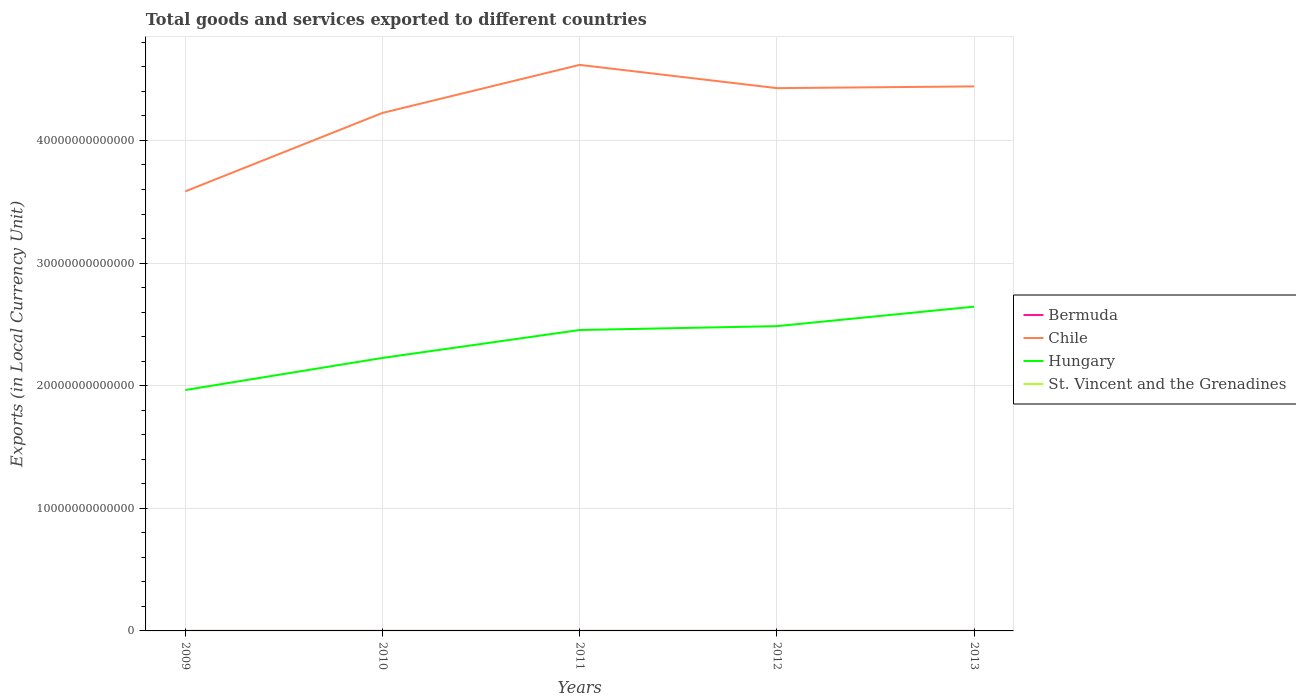How many different coloured lines are there?
Offer a very short reply. 4. Across all years, what is the maximum Amount of goods and services exports in Chile?
Offer a very short reply. 3.58e+13. In which year was the Amount of goods and services exports in Hungary maximum?
Make the answer very short. 2009. What is the total Amount of goods and services exports in Bermuda in the graph?
Your answer should be very brief. 5.48e+07. What is the difference between the highest and the second highest Amount of goods and services exports in Chile?
Your response must be concise. 1.03e+13. What is the difference between the highest and the lowest Amount of goods and services exports in Chile?
Offer a very short reply. 3. What is the difference between two consecutive major ticks on the Y-axis?
Ensure brevity in your answer.  1.00e+13. Does the graph contain grids?
Provide a succinct answer. Yes. How are the legend labels stacked?
Provide a succinct answer. Vertical. What is the title of the graph?
Your answer should be compact. Total goods and services exported to different countries. Does "Chile" appear as one of the legend labels in the graph?
Offer a very short reply. Yes. What is the label or title of the Y-axis?
Ensure brevity in your answer.  Exports (in Local Currency Unit). What is the Exports (in Local Currency Unit) in Bermuda in 2009?
Keep it short and to the point. 2.70e+09. What is the Exports (in Local Currency Unit) in Chile in 2009?
Keep it short and to the point. 3.58e+13. What is the Exports (in Local Currency Unit) of Hungary in 2009?
Your answer should be compact. 1.96e+13. What is the Exports (in Local Currency Unit) of St. Vincent and the Grenadines in 2009?
Ensure brevity in your answer.  5.19e+08. What is the Exports (in Local Currency Unit) of Bermuda in 2010?
Give a very brief answer. 2.70e+09. What is the Exports (in Local Currency Unit) of Chile in 2010?
Offer a terse response. 4.22e+13. What is the Exports (in Local Currency Unit) in Hungary in 2010?
Keep it short and to the point. 2.23e+13. What is the Exports (in Local Currency Unit) of St. Vincent and the Grenadines in 2010?
Your response must be concise. 4.95e+08. What is the Exports (in Local Currency Unit) in Bermuda in 2011?
Offer a very short reply. 2.64e+09. What is the Exports (in Local Currency Unit) in Chile in 2011?
Offer a terse response. 4.62e+13. What is the Exports (in Local Currency Unit) in Hungary in 2011?
Your response must be concise. 2.45e+13. What is the Exports (in Local Currency Unit) in St. Vincent and the Grenadines in 2011?
Your response must be concise. 4.94e+08. What is the Exports (in Local Currency Unit) in Bermuda in 2012?
Give a very brief answer. 2.59e+09. What is the Exports (in Local Currency Unit) of Chile in 2012?
Your answer should be very brief. 4.43e+13. What is the Exports (in Local Currency Unit) in Hungary in 2012?
Ensure brevity in your answer.  2.49e+13. What is the Exports (in Local Currency Unit) of St. Vincent and the Grenadines in 2012?
Provide a succinct answer. 5.15e+08. What is the Exports (in Local Currency Unit) in Bermuda in 2013?
Offer a very short reply. 2.66e+09. What is the Exports (in Local Currency Unit) in Chile in 2013?
Your response must be concise. 4.44e+13. What is the Exports (in Local Currency Unit) in Hungary in 2013?
Provide a succinct answer. 2.64e+13. What is the Exports (in Local Currency Unit) of St. Vincent and the Grenadines in 2013?
Your answer should be compact. 4.91e+08. Across all years, what is the maximum Exports (in Local Currency Unit) of Bermuda?
Provide a succinct answer. 2.70e+09. Across all years, what is the maximum Exports (in Local Currency Unit) of Chile?
Your answer should be very brief. 4.62e+13. Across all years, what is the maximum Exports (in Local Currency Unit) of Hungary?
Ensure brevity in your answer.  2.64e+13. Across all years, what is the maximum Exports (in Local Currency Unit) in St. Vincent and the Grenadines?
Give a very brief answer. 5.19e+08. Across all years, what is the minimum Exports (in Local Currency Unit) in Bermuda?
Ensure brevity in your answer.  2.59e+09. Across all years, what is the minimum Exports (in Local Currency Unit) in Chile?
Provide a short and direct response. 3.58e+13. Across all years, what is the minimum Exports (in Local Currency Unit) in Hungary?
Provide a short and direct response. 1.96e+13. Across all years, what is the minimum Exports (in Local Currency Unit) in St. Vincent and the Grenadines?
Your answer should be compact. 4.91e+08. What is the total Exports (in Local Currency Unit) of Bermuda in the graph?
Make the answer very short. 1.33e+1. What is the total Exports (in Local Currency Unit) in Chile in the graph?
Make the answer very short. 2.13e+14. What is the total Exports (in Local Currency Unit) of Hungary in the graph?
Give a very brief answer. 1.18e+14. What is the total Exports (in Local Currency Unit) of St. Vincent and the Grenadines in the graph?
Offer a terse response. 2.51e+09. What is the difference between the Exports (in Local Currency Unit) in Bermuda in 2009 and that in 2010?
Your response must be concise. -5.34e+06. What is the difference between the Exports (in Local Currency Unit) in Chile in 2009 and that in 2010?
Make the answer very short. -6.40e+12. What is the difference between the Exports (in Local Currency Unit) of Hungary in 2009 and that in 2010?
Offer a terse response. -2.62e+12. What is the difference between the Exports (in Local Currency Unit) in St. Vincent and the Grenadines in 2009 and that in 2010?
Provide a succinct answer. 2.46e+07. What is the difference between the Exports (in Local Currency Unit) of Bermuda in 2009 and that in 2011?
Your answer should be compact. 5.51e+07. What is the difference between the Exports (in Local Currency Unit) of Chile in 2009 and that in 2011?
Provide a short and direct response. -1.03e+13. What is the difference between the Exports (in Local Currency Unit) in Hungary in 2009 and that in 2011?
Offer a very short reply. -4.89e+12. What is the difference between the Exports (in Local Currency Unit) in St. Vincent and the Grenadines in 2009 and that in 2011?
Make the answer very short. 2.57e+07. What is the difference between the Exports (in Local Currency Unit) of Bermuda in 2009 and that in 2012?
Your answer should be compact. 1.10e+08. What is the difference between the Exports (in Local Currency Unit) in Chile in 2009 and that in 2012?
Make the answer very short. -8.42e+12. What is the difference between the Exports (in Local Currency Unit) of Hungary in 2009 and that in 2012?
Provide a short and direct response. -5.21e+12. What is the difference between the Exports (in Local Currency Unit) in St. Vincent and the Grenadines in 2009 and that in 2012?
Keep it short and to the point. 4.42e+06. What is the difference between the Exports (in Local Currency Unit) of Bermuda in 2009 and that in 2013?
Offer a terse response. 4.24e+07. What is the difference between the Exports (in Local Currency Unit) in Chile in 2009 and that in 2013?
Your answer should be compact. -8.56e+12. What is the difference between the Exports (in Local Currency Unit) of Hungary in 2009 and that in 2013?
Your answer should be compact. -6.80e+12. What is the difference between the Exports (in Local Currency Unit) in St. Vincent and the Grenadines in 2009 and that in 2013?
Your answer should be compact. 2.79e+07. What is the difference between the Exports (in Local Currency Unit) in Bermuda in 2010 and that in 2011?
Offer a terse response. 6.04e+07. What is the difference between the Exports (in Local Currency Unit) of Chile in 2010 and that in 2011?
Make the answer very short. -3.92e+12. What is the difference between the Exports (in Local Currency Unit) of Hungary in 2010 and that in 2011?
Offer a very short reply. -2.28e+12. What is the difference between the Exports (in Local Currency Unit) in St. Vincent and the Grenadines in 2010 and that in 2011?
Offer a very short reply. 1.06e+06. What is the difference between the Exports (in Local Currency Unit) of Bermuda in 2010 and that in 2012?
Your answer should be compact. 1.15e+08. What is the difference between the Exports (in Local Currency Unit) of Chile in 2010 and that in 2012?
Your answer should be very brief. -2.02e+12. What is the difference between the Exports (in Local Currency Unit) in Hungary in 2010 and that in 2012?
Make the answer very short. -2.59e+12. What is the difference between the Exports (in Local Currency Unit) of St. Vincent and the Grenadines in 2010 and that in 2012?
Give a very brief answer. -2.02e+07. What is the difference between the Exports (in Local Currency Unit) of Bermuda in 2010 and that in 2013?
Offer a very short reply. 4.78e+07. What is the difference between the Exports (in Local Currency Unit) of Chile in 2010 and that in 2013?
Your answer should be compact. -2.16e+12. What is the difference between the Exports (in Local Currency Unit) of Hungary in 2010 and that in 2013?
Provide a short and direct response. -4.18e+12. What is the difference between the Exports (in Local Currency Unit) of St. Vincent and the Grenadines in 2010 and that in 2013?
Your response must be concise. 3.31e+06. What is the difference between the Exports (in Local Currency Unit) in Bermuda in 2011 and that in 2012?
Ensure brevity in your answer.  5.48e+07. What is the difference between the Exports (in Local Currency Unit) in Chile in 2011 and that in 2012?
Give a very brief answer. 1.90e+12. What is the difference between the Exports (in Local Currency Unit) of Hungary in 2011 and that in 2012?
Provide a short and direct response. -3.15e+11. What is the difference between the Exports (in Local Currency Unit) of St. Vincent and the Grenadines in 2011 and that in 2012?
Provide a succinct answer. -2.13e+07. What is the difference between the Exports (in Local Currency Unit) in Bermuda in 2011 and that in 2013?
Ensure brevity in your answer.  -1.27e+07. What is the difference between the Exports (in Local Currency Unit) of Chile in 2011 and that in 2013?
Provide a short and direct response. 1.76e+12. What is the difference between the Exports (in Local Currency Unit) of Hungary in 2011 and that in 2013?
Keep it short and to the point. -1.90e+12. What is the difference between the Exports (in Local Currency Unit) in St. Vincent and the Grenadines in 2011 and that in 2013?
Provide a succinct answer. 2.26e+06. What is the difference between the Exports (in Local Currency Unit) of Bermuda in 2012 and that in 2013?
Your answer should be very brief. -6.75e+07. What is the difference between the Exports (in Local Currency Unit) in Chile in 2012 and that in 2013?
Keep it short and to the point. -1.41e+11. What is the difference between the Exports (in Local Currency Unit) of Hungary in 2012 and that in 2013?
Keep it short and to the point. -1.59e+12. What is the difference between the Exports (in Local Currency Unit) in St. Vincent and the Grenadines in 2012 and that in 2013?
Provide a short and direct response. 2.35e+07. What is the difference between the Exports (in Local Currency Unit) of Bermuda in 2009 and the Exports (in Local Currency Unit) of Chile in 2010?
Offer a very short reply. -4.22e+13. What is the difference between the Exports (in Local Currency Unit) in Bermuda in 2009 and the Exports (in Local Currency Unit) in Hungary in 2010?
Provide a short and direct response. -2.23e+13. What is the difference between the Exports (in Local Currency Unit) of Bermuda in 2009 and the Exports (in Local Currency Unit) of St. Vincent and the Grenadines in 2010?
Your answer should be compact. 2.20e+09. What is the difference between the Exports (in Local Currency Unit) of Chile in 2009 and the Exports (in Local Currency Unit) of Hungary in 2010?
Your response must be concise. 1.36e+13. What is the difference between the Exports (in Local Currency Unit) of Chile in 2009 and the Exports (in Local Currency Unit) of St. Vincent and the Grenadines in 2010?
Ensure brevity in your answer.  3.58e+13. What is the difference between the Exports (in Local Currency Unit) of Hungary in 2009 and the Exports (in Local Currency Unit) of St. Vincent and the Grenadines in 2010?
Ensure brevity in your answer.  1.96e+13. What is the difference between the Exports (in Local Currency Unit) of Bermuda in 2009 and the Exports (in Local Currency Unit) of Chile in 2011?
Offer a very short reply. -4.62e+13. What is the difference between the Exports (in Local Currency Unit) of Bermuda in 2009 and the Exports (in Local Currency Unit) of Hungary in 2011?
Your response must be concise. -2.45e+13. What is the difference between the Exports (in Local Currency Unit) in Bermuda in 2009 and the Exports (in Local Currency Unit) in St. Vincent and the Grenadines in 2011?
Your answer should be compact. 2.21e+09. What is the difference between the Exports (in Local Currency Unit) of Chile in 2009 and the Exports (in Local Currency Unit) of Hungary in 2011?
Your response must be concise. 1.13e+13. What is the difference between the Exports (in Local Currency Unit) in Chile in 2009 and the Exports (in Local Currency Unit) in St. Vincent and the Grenadines in 2011?
Make the answer very short. 3.58e+13. What is the difference between the Exports (in Local Currency Unit) in Hungary in 2009 and the Exports (in Local Currency Unit) in St. Vincent and the Grenadines in 2011?
Your response must be concise. 1.96e+13. What is the difference between the Exports (in Local Currency Unit) of Bermuda in 2009 and the Exports (in Local Currency Unit) of Chile in 2012?
Ensure brevity in your answer.  -4.43e+13. What is the difference between the Exports (in Local Currency Unit) of Bermuda in 2009 and the Exports (in Local Currency Unit) of Hungary in 2012?
Provide a succinct answer. -2.49e+13. What is the difference between the Exports (in Local Currency Unit) of Bermuda in 2009 and the Exports (in Local Currency Unit) of St. Vincent and the Grenadines in 2012?
Offer a very short reply. 2.18e+09. What is the difference between the Exports (in Local Currency Unit) in Chile in 2009 and the Exports (in Local Currency Unit) in Hungary in 2012?
Provide a short and direct response. 1.10e+13. What is the difference between the Exports (in Local Currency Unit) of Chile in 2009 and the Exports (in Local Currency Unit) of St. Vincent and the Grenadines in 2012?
Make the answer very short. 3.58e+13. What is the difference between the Exports (in Local Currency Unit) of Hungary in 2009 and the Exports (in Local Currency Unit) of St. Vincent and the Grenadines in 2012?
Your answer should be compact. 1.96e+13. What is the difference between the Exports (in Local Currency Unit) in Bermuda in 2009 and the Exports (in Local Currency Unit) in Chile in 2013?
Your response must be concise. -4.44e+13. What is the difference between the Exports (in Local Currency Unit) in Bermuda in 2009 and the Exports (in Local Currency Unit) in Hungary in 2013?
Provide a succinct answer. -2.64e+13. What is the difference between the Exports (in Local Currency Unit) of Bermuda in 2009 and the Exports (in Local Currency Unit) of St. Vincent and the Grenadines in 2013?
Give a very brief answer. 2.21e+09. What is the difference between the Exports (in Local Currency Unit) in Chile in 2009 and the Exports (in Local Currency Unit) in Hungary in 2013?
Offer a terse response. 9.40e+12. What is the difference between the Exports (in Local Currency Unit) in Chile in 2009 and the Exports (in Local Currency Unit) in St. Vincent and the Grenadines in 2013?
Give a very brief answer. 3.58e+13. What is the difference between the Exports (in Local Currency Unit) in Hungary in 2009 and the Exports (in Local Currency Unit) in St. Vincent and the Grenadines in 2013?
Ensure brevity in your answer.  1.96e+13. What is the difference between the Exports (in Local Currency Unit) of Bermuda in 2010 and the Exports (in Local Currency Unit) of Chile in 2011?
Your answer should be compact. -4.62e+13. What is the difference between the Exports (in Local Currency Unit) of Bermuda in 2010 and the Exports (in Local Currency Unit) of Hungary in 2011?
Ensure brevity in your answer.  -2.45e+13. What is the difference between the Exports (in Local Currency Unit) in Bermuda in 2010 and the Exports (in Local Currency Unit) in St. Vincent and the Grenadines in 2011?
Your response must be concise. 2.21e+09. What is the difference between the Exports (in Local Currency Unit) in Chile in 2010 and the Exports (in Local Currency Unit) in Hungary in 2011?
Your response must be concise. 1.77e+13. What is the difference between the Exports (in Local Currency Unit) in Chile in 2010 and the Exports (in Local Currency Unit) in St. Vincent and the Grenadines in 2011?
Provide a short and direct response. 4.22e+13. What is the difference between the Exports (in Local Currency Unit) in Hungary in 2010 and the Exports (in Local Currency Unit) in St. Vincent and the Grenadines in 2011?
Your answer should be very brief. 2.23e+13. What is the difference between the Exports (in Local Currency Unit) in Bermuda in 2010 and the Exports (in Local Currency Unit) in Chile in 2012?
Keep it short and to the point. -4.43e+13. What is the difference between the Exports (in Local Currency Unit) of Bermuda in 2010 and the Exports (in Local Currency Unit) of Hungary in 2012?
Your response must be concise. -2.49e+13. What is the difference between the Exports (in Local Currency Unit) of Bermuda in 2010 and the Exports (in Local Currency Unit) of St. Vincent and the Grenadines in 2012?
Provide a succinct answer. 2.19e+09. What is the difference between the Exports (in Local Currency Unit) of Chile in 2010 and the Exports (in Local Currency Unit) of Hungary in 2012?
Your answer should be very brief. 1.74e+13. What is the difference between the Exports (in Local Currency Unit) in Chile in 2010 and the Exports (in Local Currency Unit) in St. Vincent and the Grenadines in 2012?
Make the answer very short. 4.22e+13. What is the difference between the Exports (in Local Currency Unit) of Hungary in 2010 and the Exports (in Local Currency Unit) of St. Vincent and the Grenadines in 2012?
Your answer should be compact. 2.23e+13. What is the difference between the Exports (in Local Currency Unit) of Bermuda in 2010 and the Exports (in Local Currency Unit) of Chile in 2013?
Make the answer very short. -4.44e+13. What is the difference between the Exports (in Local Currency Unit) in Bermuda in 2010 and the Exports (in Local Currency Unit) in Hungary in 2013?
Your answer should be very brief. -2.64e+13. What is the difference between the Exports (in Local Currency Unit) in Bermuda in 2010 and the Exports (in Local Currency Unit) in St. Vincent and the Grenadines in 2013?
Provide a succinct answer. 2.21e+09. What is the difference between the Exports (in Local Currency Unit) in Chile in 2010 and the Exports (in Local Currency Unit) in Hungary in 2013?
Give a very brief answer. 1.58e+13. What is the difference between the Exports (in Local Currency Unit) in Chile in 2010 and the Exports (in Local Currency Unit) in St. Vincent and the Grenadines in 2013?
Provide a short and direct response. 4.22e+13. What is the difference between the Exports (in Local Currency Unit) in Hungary in 2010 and the Exports (in Local Currency Unit) in St. Vincent and the Grenadines in 2013?
Offer a very short reply. 2.23e+13. What is the difference between the Exports (in Local Currency Unit) in Bermuda in 2011 and the Exports (in Local Currency Unit) in Chile in 2012?
Your response must be concise. -4.43e+13. What is the difference between the Exports (in Local Currency Unit) in Bermuda in 2011 and the Exports (in Local Currency Unit) in Hungary in 2012?
Your response must be concise. -2.49e+13. What is the difference between the Exports (in Local Currency Unit) in Bermuda in 2011 and the Exports (in Local Currency Unit) in St. Vincent and the Grenadines in 2012?
Offer a terse response. 2.13e+09. What is the difference between the Exports (in Local Currency Unit) of Chile in 2011 and the Exports (in Local Currency Unit) of Hungary in 2012?
Your answer should be compact. 2.13e+13. What is the difference between the Exports (in Local Currency Unit) of Chile in 2011 and the Exports (in Local Currency Unit) of St. Vincent and the Grenadines in 2012?
Your answer should be very brief. 4.62e+13. What is the difference between the Exports (in Local Currency Unit) in Hungary in 2011 and the Exports (in Local Currency Unit) in St. Vincent and the Grenadines in 2012?
Your answer should be very brief. 2.45e+13. What is the difference between the Exports (in Local Currency Unit) of Bermuda in 2011 and the Exports (in Local Currency Unit) of Chile in 2013?
Give a very brief answer. -4.44e+13. What is the difference between the Exports (in Local Currency Unit) in Bermuda in 2011 and the Exports (in Local Currency Unit) in Hungary in 2013?
Your response must be concise. -2.64e+13. What is the difference between the Exports (in Local Currency Unit) of Bermuda in 2011 and the Exports (in Local Currency Unit) of St. Vincent and the Grenadines in 2013?
Ensure brevity in your answer.  2.15e+09. What is the difference between the Exports (in Local Currency Unit) in Chile in 2011 and the Exports (in Local Currency Unit) in Hungary in 2013?
Provide a succinct answer. 1.97e+13. What is the difference between the Exports (in Local Currency Unit) of Chile in 2011 and the Exports (in Local Currency Unit) of St. Vincent and the Grenadines in 2013?
Your answer should be compact. 4.62e+13. What is the difference between the Exports (in Local Currency Unit) of Hungary in 2011 and the Exports (in Local Currency Unit) of St. Vincent and the Grenadines in 2013?
Offer a very short reply. 2.45e+13. What is the difference between the Exports (in Local Currency Unit) in Bermuda in 2012 and the Exports (in Local Currency Unit) in Chile in 2013?
Provide a succinct answer. -4.44e+13. What is the difference between the Exports (in Local Currency Unit) in Bermuda in 2012 and the Exports (in Local Currency Unit) in Hungary in 2013?
Make the answer very short. -2.64e+13. What is the difference between the Exports (in Local Currency Unit) in Bermuda in 2012 and the Exports (in Local Currency Unit) in St. Vincent and the Grenadines in 2013?
Make the answer very short. 2.10e+09. What is the difference between the Exports (in Local Currency Unit) of Chile in 2012 and the Exports (in Local Currency Unit) of Hungary in 2013?
Keep it short and to the point. 1.78e+13. What is the difference between the Exports (in Local Currency Unit) of Chile in 2012 and the Exports (in Local Currency Unit) of St. Vincent and the Grenadines in 2013?
Provide a short and direct response. 4.43e+13. What is the difference between the Exports (in Local Currency Unit) of Hungary in 2012 and the Exports (in Local Currency Unit) of St. Vincent and the Grenadines in 2013?
Ensure brevity in your answer.  2.49e+13. What is the average Exports (in Local Currency Unit) of Bermuda per year?
Provide a succinct answer. 2.66e+09. What is the average Exports (in Local Currency Unit) in Chile per year?
Make the answer very short. 4.26e+13. What is the average Exports (in Local Currency Unit) of Hungary per year?
Keep it short and to the point. 2.36e+13. What is the average Exports (in Local Currency Unit) in St. Vincent and the Grenadines per year?
Your response must be concise. 5.03e+08. In the year 2009, what is the difference between the Exports (in Local Currency Unit) in Bermuda and Exports (in Local Currency Unit) in Chile?
Keep it short and to the point. -3.58e+13. In the year 2009, what is the difference between the Exports (in Local Currency Unit) in Bermuda and Exports (in Local Currency Unit) in Hungary?
Your response must be concise. -1.96e+13. In the year 2009, what is the difference between the Exports (in Local Currency Unit) of Bermuda and Exports (in Local Currency Unit) of St. Vincent and the Grenadines?
Make the answer very short. 2.18e+09. In the year 2009, what is the difference between the Exports (in Local Currency Unit) in Chile and Exports (in Local Currency Unit) in Hungary?
Your answer should be compact. 1.62e+13. In the year 2009, what is the difference between the Exports (in Local Currency Unit) of Chile and Exports (in Local Currency Unit) of St. Vincent and the Grenadines?
Offer a very short reply. 3.58e+13. In the year 2009, what is the difference between the Exports (in Local Currency Unit) in Hungary and Exports (in Local Currency Unit) in St. Vincent and the Grenadines?
Your response must be concise. 1.96e+13. In the year 2010, what is the difference between the Exports (in Local Currency Unit) in Bermuda and Exports (in Local Currency Unit) in Chile?
Provide a succinct answer. -4.22e+13. In the year 2010, what is the difference between the Exports (in Local Currency Unit) in Bermuda and Exports (in Local Currency Unit) in Hungary?
Your response must be concise. -2.23e+13. In the year 2010, what is the difference between the Exports (in Local Currency Unit) in Bermuda and Exports (in Local Currency Unit) in St. Vincent and the Grenadines?
Keep it short and to the point. 2.21e+09. In the year 2010, what is the difference between the Exports (in Local Currency Unit) of Chile and Exports (in Local Currency Unit) of Hungary?
Ensure brevity in your answer.  2.00e+13. In the year 2010, what is the difference between the Exports (in Local Currency Unit) of Chile and Exports (in Local Currency Unit) of St. Vincent and the Grenadines?
Offer a very short reply. 4.22e+13. In the year 2010, what is the difference between the Exports (in Local Currency Unit) in Hungary and Exports (in Local Currency Unit) in St. Vincent and the Grenadines?
Provide a succinct answer. 2.23e+13. In the year 2011, what is the difference between the Exports (in Local Currency Unit) of Bermuda and Exports (in Local Currency Unit) of Chile?
Provide a short and direct response. -4.62e+13. In the year 2011, what is the difference between the Exports (in Local Currency Unit) in Bermuda and Exports (in Local Currency Unit) in Hungary?
Keep it short and to the point. -2.45e+13. In the year 2011, what is the difference between the Exports (in Local Currency Unit) of Bermuda and Exports (in Local Currency Unit) of St. Vincent and the Grenadines?
Provide a short and direct response. 2.15e+09. In the year 2011, what is the difference between the Exports (in Local Currency Unit) of Chile and Exports (in Local Currency Unit) of Hungary?
Your answer should be compact. 2.16e+13. In the year 2011, what is the difference between the Exports (in Local Currency Unit) in Chile and Exports (in Local Currency Unit) in St. Vincent and the Grenadines?
Provide a succinct answer. 4.62e+13. In the year 2011, what is the difference between the Exports (in Local Currency Unit) of Hungary and Exports (in Local Currency Unit) of St. Vincent and the Grenadines?
Provide a short and direct response. 2.45e+13. In the year 2012, what is the difference between the Exports (in Local Currency Unit) in Bermuda and Exports (in Local Currency Unit) in Chile?
Make the answer very short. -4.43e+13. In the year 2012, what is the difference between the Exports (in Local Currency Unit) of Bermuda and Exports (in Local Currency Unit) of Hungary?
Provide a short and direct response. -2.49e+13. In the year 2012, what is the difference between the Exports (in Local Currency Unit) in Bermuda and Exports (in Local Currency Unit) in St. Vincent and the Grenadines?
Make the answer very short. 2.07e+09. In the year 2012, what is the difference between the Exports (in Local Currency Unit) in Chile and Exports (in Local Currency Unit) in Hungary?
Your response must be concise. 1.94e+13. In the year 2012, what is the difference between the Exports (in Local Currency Unit) in Chile and Exports (in Local Currency Unit) in St. Vincent and the Grenadines?
Offer a very short reply. 4.43e+13. In the year 2012, what is the difference between the Exports (in Local Currency Unit) in Hungary and Exports (in Local Currency Unit) in St. Vincent and the Grenadines?
Ensure brevity in your answer.  2.49e+13. In the year 2013, what is the difference between the Exports (in Local Currency Unit) of Bermuda and Exports (in Local Currency Unit) of Chile?
Your answer should be very brief. -4.44e+13. In the year 2013, what is the difference between the Exports (in Local Currency Unit) of Bermuda and Exports (in Local Currency Unit) of Hungary?
Your response must be concise. -2.64e+13. In the year 2013, what is the difference between the Exports (in Local Currency Unit) of Bermuda and Exports (in Local Currency Unit) of St. Vincent and the Grenadines?
Keep it short and to the point. 2.17e+09. In the year 2013, what is the difference between the Exports (in Local Currency Unit) in Chile and Exports (in Local Currency Unit) in Hungary?
Your answer should be compact. 1.80e+13. In the year 2013, what is the difference between the Exports (in Local Currency Unit) of Chile and Exports (in Local Currency Unit) of St. Vincent and the Grenadines?
Keep it short and to the point. 4.44e+13. In the year 2013, what is the difference between the Exports (in Local Currency Unit) of Hungary and Exports (in Local Currency Unit) of St. Vincent and the Grenadines?
Offer a terse response. 2.64e+13. What is the ratio of the Exports (in Local Currency Unit) in Chile in 2009 to that in 2010?
Your response must be concise. 0.85. What is the ratio of the Exports (in Local Currency Unit) of Hungary in 2009 to that in 2010?
Ensure brevity in your answer.  0.88. What is the ratio of the Exports (in Local Currency Unit) in St. Vincent and the Grenadines in 2009 to that in 2010?
Your answer should be very brief. 1.05. What is the ratio of the Exports (in Local Currency Unit) of Bermuda in 2009 to that in 2011?
Your response must be concise. 1.02. What is the ratio of the Exports (in Local Currency Unit) of Chile in 2009 to that in 2011?
Your answer should be very brief. 0.78. What is the ratio of the Exports (in Local Currency Unit) of Hungary in 2009 to that in 2011?
Your answer should be compact. 0.8. What is the ratio of the Exports (in Local Currency Unit) in St. Vincent and the Grenadines in 2009 to that in 2011?
Offer a very short reply. 1.05. What is the ratio of the Exports (in Local Currency Unit) in Bermuda in 2009 to that in 2012?
Offer a terse response. 1.04. What is the ratio of the Exports (in Local Currency Unit) in Chile in 2009 to that in 2012?
Your answer should be compact. 0.81. What is the ratio of the Exports (in Local Currency Unit) of Hungary in 2009 to that in 2012?
Your answer should be very brief. 0.79. What is the ratio of the Exports (in Local Currency Unit) of St. Vincent and the Grenadines in 2009 to that in 2012?
Give a very brief answer. 1.01. What is the ratio of the Exports (in Local Currency Unit) in Bermuda in 2009 to that in 2013?
Provide a succinct answer. 1.02. What is the ratio of the Exports (in Local Currency Unit) in Chile in 2009 to that in 2013?
Keep it short and to the point. 0.81. What is the ratio of the Exports (in Local Currency Unit) in Hungary in 2009 to that in 2013?
Ensure brevity in your answer.  0.74. What is the ratio of the Exports (in Local Currency Unit) of St. Vincent and the Grenadines in 2009 to that in 2013?
Provide a short and direct response. 1.06. What is the ratio of the Exports (in Local Currency Unit) in Bermuda in 2010 to that in 2011?
Your answer should be very brief. 1.02. What is the ratio of the Exports (in Local Currency Unit) of Chile in 2010 to that in 2011?
Provide a succinct answer. 0.92. What is the ratio of the Exports (in Local Currency Unit) in Hungary in 2010 to that in 2011?
Give a very brief answer. 0.91. What is the ratio of the Exports (in Local Currency Unit) of St. Vincent and the Grenadines in 2010 to that in 2011?
Your response must be concise. 1. What is the ratio of the Exports (in Local Currency Unit) of Bermuda in 2010 to that in 2012?
Ensure brevity in your answer.  1.04. What is the ratio of the Exports (in Local Currency Unit) of Chile in 2010 to that in 2012?
Provide a short and direct response. 0.95. What is the ratio of the Exports (in Local Currency Unit) of Hungary in 2010 to that in 2012?
Provide a succinct answer. 0.9. What is the ratio of the Exports (in Local Currency Unit) of St. Vincent and the Grenadines in 2010 to that in 2012?
Give a very brief answer. 0.96. What is the ratio of the Exports (in Local Currency Unit) of Bermuda in 2010 to that in 2013?
Provide a succinct answer. 1.02. What is the ratio of the Exports (in Local Currency Unit) of Chile in 2010 to that in 2013?
Make the answer very short. 0.95. What is the ratio of the Exports (in Local Currency Unit) of Hungary in 2010 to that in 2013?
Provide a succinct answer. 0.84. What is the ratio of the Exports (in Local Currency Unit) in St. Vincent and the Grenadines in 2010 to that in 2013?
Your answer should be very brief. 1.01. What is the ratio of the Exports (in Local Currency Unit) of Bermuda in 2011 to that in 2012?
Your answer should be very brief. 1.02. What is the ratio of the Exports (in Local Currency Unit) of Chile in 2011 to that in 2012?
Make the answer very short. 1.04. What is the ratio of the Exports (in Local Currency Unit) in Hungary in 2011 to that in 2012?
Provide a short and direct response. 0.99. What is the ratio of the Exports (in Local Currency Unit) in St. Vincent and the Grenadines in 2011 to that in 2012?
Your answer should be very brief. 0.96. What is the ratio of the Exports (in Local Currency Unit) of Bermuda in 2011 to that in 2013?
Offer a terse response. 1. What is the ratio of the Exports (in Local Currency Unit) in Chile in 2011 to that in 2013?
Keep it short and to the point. 1.04. What is the ratio of the Exports (in Local Currency Unit) of Hungary in 2011 to that in 2013?
Your response must be concise. 0.93. What is the ratio of the Exports (in Local Currency Unit) in St. Vincent and the Grenadines in 2011 to that in 2013?
Provide a short and direct response. 1. What is the ratio of the Exports (in Local Currency Unit) of Bermuda in 2012 to that in 2013?
Your response must be concise. 0.97. What is the ratio of the Exports (in Local Currency Unit) of Chile in 2012 to that in 2013?
Offer a terse response. 1. What is the ratio of the Exports (in Local Currency Unit) of Hungary in 2012 to that in 2013?
Your answer should be very brief. 0.94. What is the ratio of the Exports (in Local Currency Unit) of St. Vincent and the Grenadines in 2012 to that in 2013?
Make the answer very short. 1.05. What is the difference between the highest and the second highest Exports (in Local Currency Unit) in Bermuda?
Make the answer very short. 5.34e+06. What is the difference between the highest and the second highest Exports (in Local Currency Unit) of Chile?
Your answer should be compact. 1.76e+12. What is the difference between the highest and the second highest Exports (in Local Currency Unit) of Hungary?
Your answer should be very brief. 1.59e+12. What is the difference between the highest and the second highest Exports (in Local Currency Unit) of St. Vincent and the Grenadines?
Provide a short and direct response. 4.42e+06. What is the difference between the highest and the lowest Exports (in Local Currency Unit) in Bermuda?
Provide a short and direct response. 1.15e+08. What is the difference between the highest and the lowest Exports (in Local Currency Unit) in Chile?
Your answer should be very brief. 1.03e+13. What is the difference between the highest and the lowest Exports (in Local Currency Unit) in Hungary?
Your response must be concise. 6.80e+12. What is the difference between the highest and the lowest Exports (in Local Currency Unit) in St. Vincent and the Grenadines?
Keep it short and to the point. 2.79e+07. 